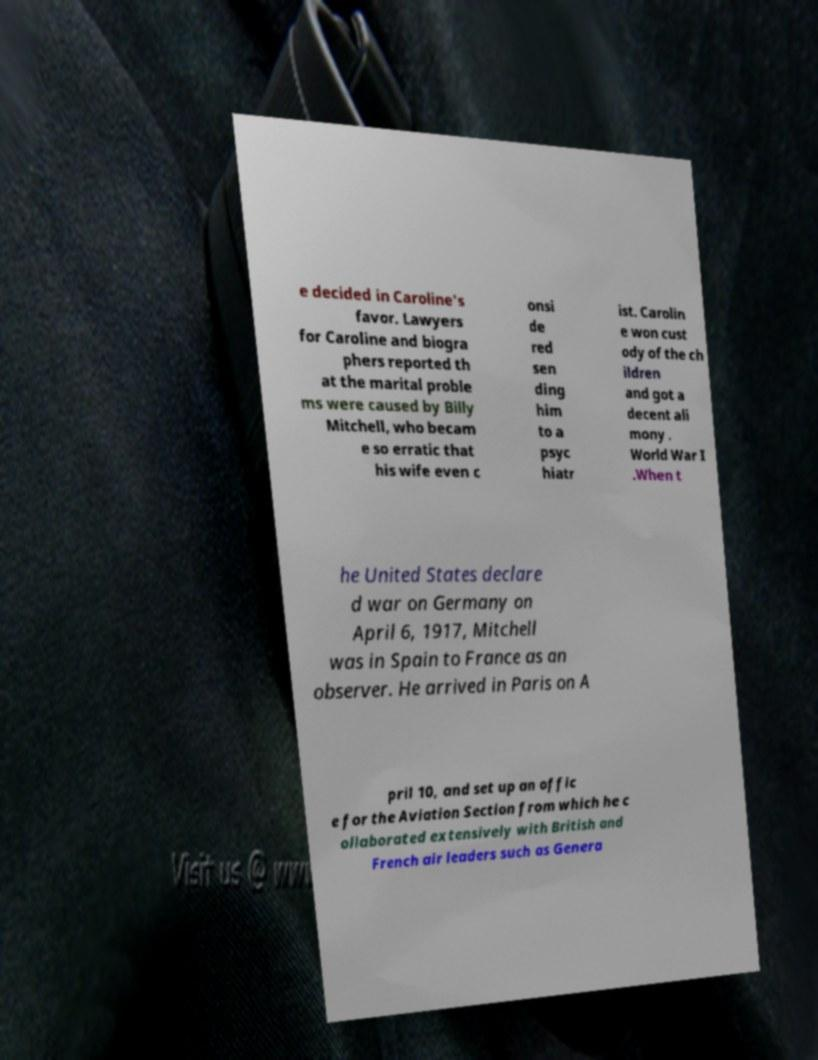I need the written content from this picture converted into text. Can you do that? e decided in Caroline's favor. Lawyers for Caroline and biogra phers reported th at the marital proble ms were caused by Billy Mitchell, who becam e so erratic that his wife even c onsi de red sen ding him to a psyc hiatr ist. Carolin e won cust ody of the ch ildren and got a decent ali mony . World War I .When t he United States declare d war on Germany on April 6, 1917, Mitchell was in Spain to France as an observer. He arrived in Paris on A pril 10, and set up an offic e for the Aviation Section from which he c ollaborated extensively with British and French air leaders such as Genera 